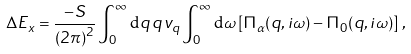Convert formula to latex. <formula><loc_0><loc_0><loc_500><loc_500>\Delta E _ { x } = \frac { - S } { \left ( 2 \pi \right ) ^ { 2 } } \int _ { 0 } ^ { \infty } { \mathrm d } q \, q \, v _ { q } \int _ { 0 } ^ { \infty } { \mathrm d } \omega \left [ \Pi _ { \alpha } ( q , i \omega ) - \Pi _ { 0 } ( q , i \omega ) \right ] \, ,</formula> 